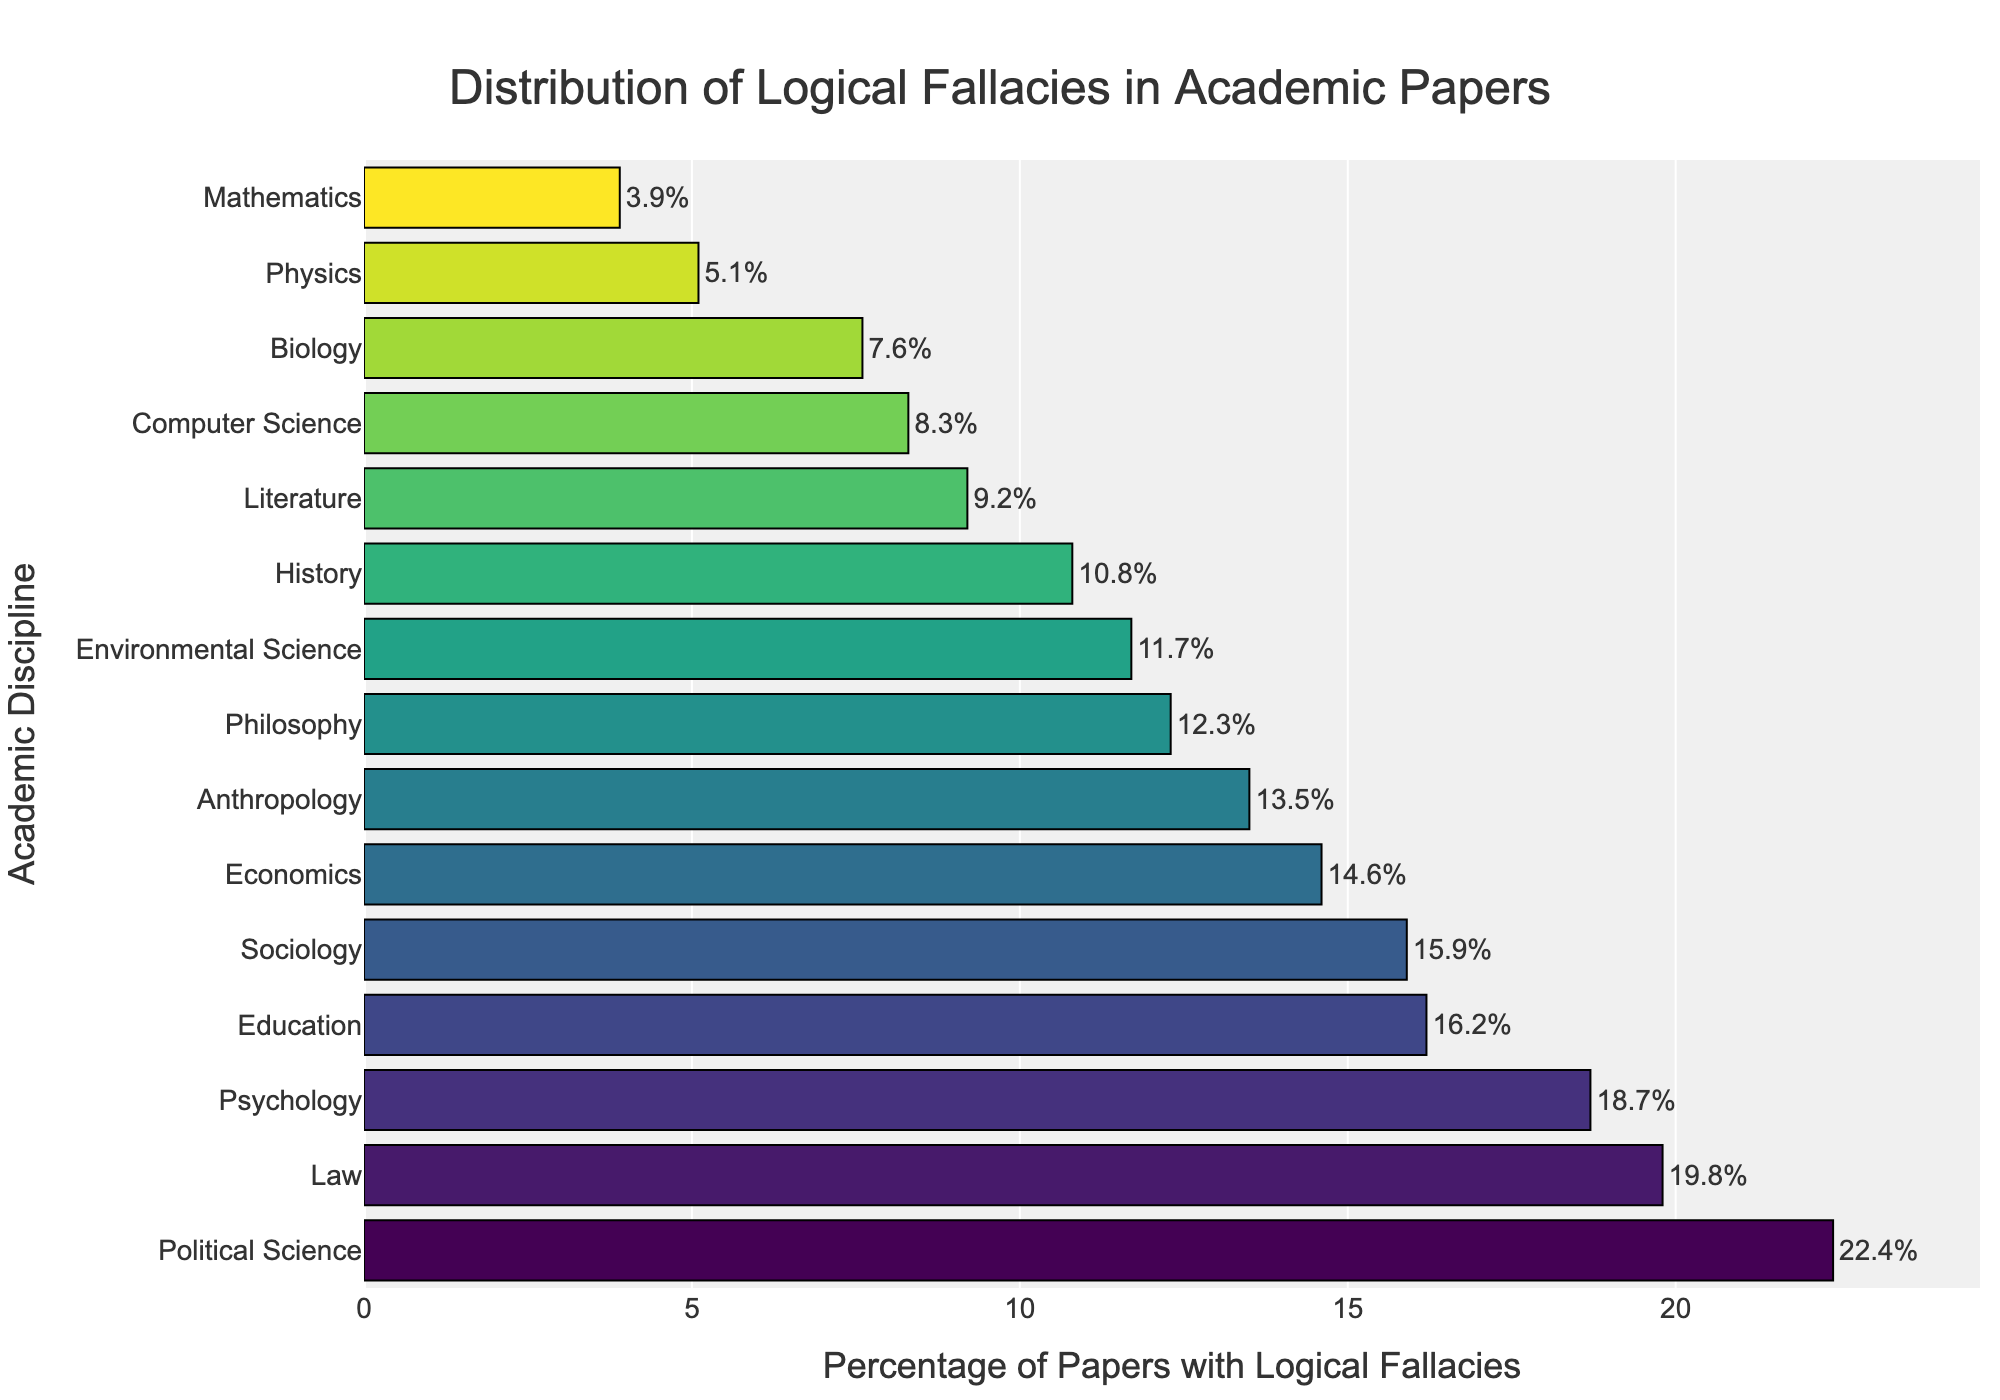Which discipline has the highest percentage of papers with logical fallacies? Political Science has the highest percentage because its bar extends the furthest to the right.
Answer: Political Science Which discipline has the lowest percentage of papers with logical fallacies? Mathematics has the lowest percentage because its bar is the shortest.
Answer: Mathematics How much higher is the percentage of logical fallacies in Psychology compared to Physics? Psychology has 18.7%, while Physics has 5.1%. The difference is 18.7 - 5.1 = 13.6%.
Answer: 13.6% What is the average percentage of logical fallacies across the disciplines of Philosophy, Economics, and History? Sum the percentages for Philosophy, Economics, and History: 12.3 + 14.6 + 10.8 = 37.7. Then, divide by 3 to find the average: 37.7 / 3 ≈ 12.57%.
Answer: 12.57% Which two disciplines have almost equal percentages of logical fallacies? Anthropology and Philosophy appear to have very close percentages, with Anthropology at 13.5% and Philosophy at 12.3%.
Answer: Anthropology and Philosophy Compare the percentage of logical fallacies in Education to that in Environmental Science. Which is higher? Education has a higher percentage than Environmental Science. Education is at 16.2%, while Environmental Science is at 11.7%.
Answer: Education What is the total percentage of papers with logical fallacies for the top three disciplines? The top three disciplines are Political Science (22.4%), Law (19.8%), and Psychology (18.7%). The total is 22.4 + 19.8 + 18.7 = 60.9%.
Answer: 60.9% How does the percentage of logical fallacies in Literature compare to that in Biology? Literature and Biology have relatively similar low percentages, with Literature at 9.2% and Biology at 7.6%. Literature has a slightly higher percentage than Biology.
Answer: Literature Which disciplines have a percentage of logical fallacies greater than 15%? The disciplines with percentages greater than 15% are Political Science (22.4%), Law (19.8%), Psychology (18.7%), Sociology (15.9%), and Education (16.2%).
Answer: Political Science, Law, Psychology, Sociology, and Education 